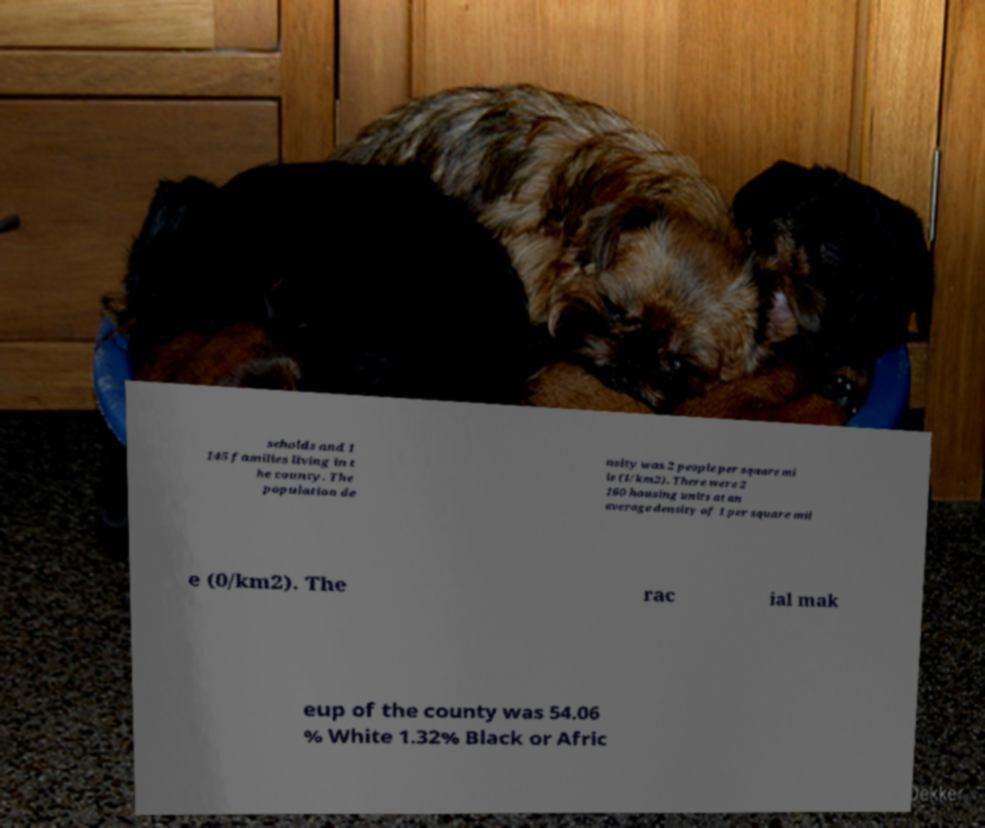Can you accurately transcribe the text from the provided image for me? seholds and 1 145 families living in t he county. The population de nsity was 2 people per square mi le (1/km2). There were 2 160 housing units at an average density of 1 per square mil e (0/km2). The rac ial mak eup of the county was 54.06 % White 1.32% Black or Afric 